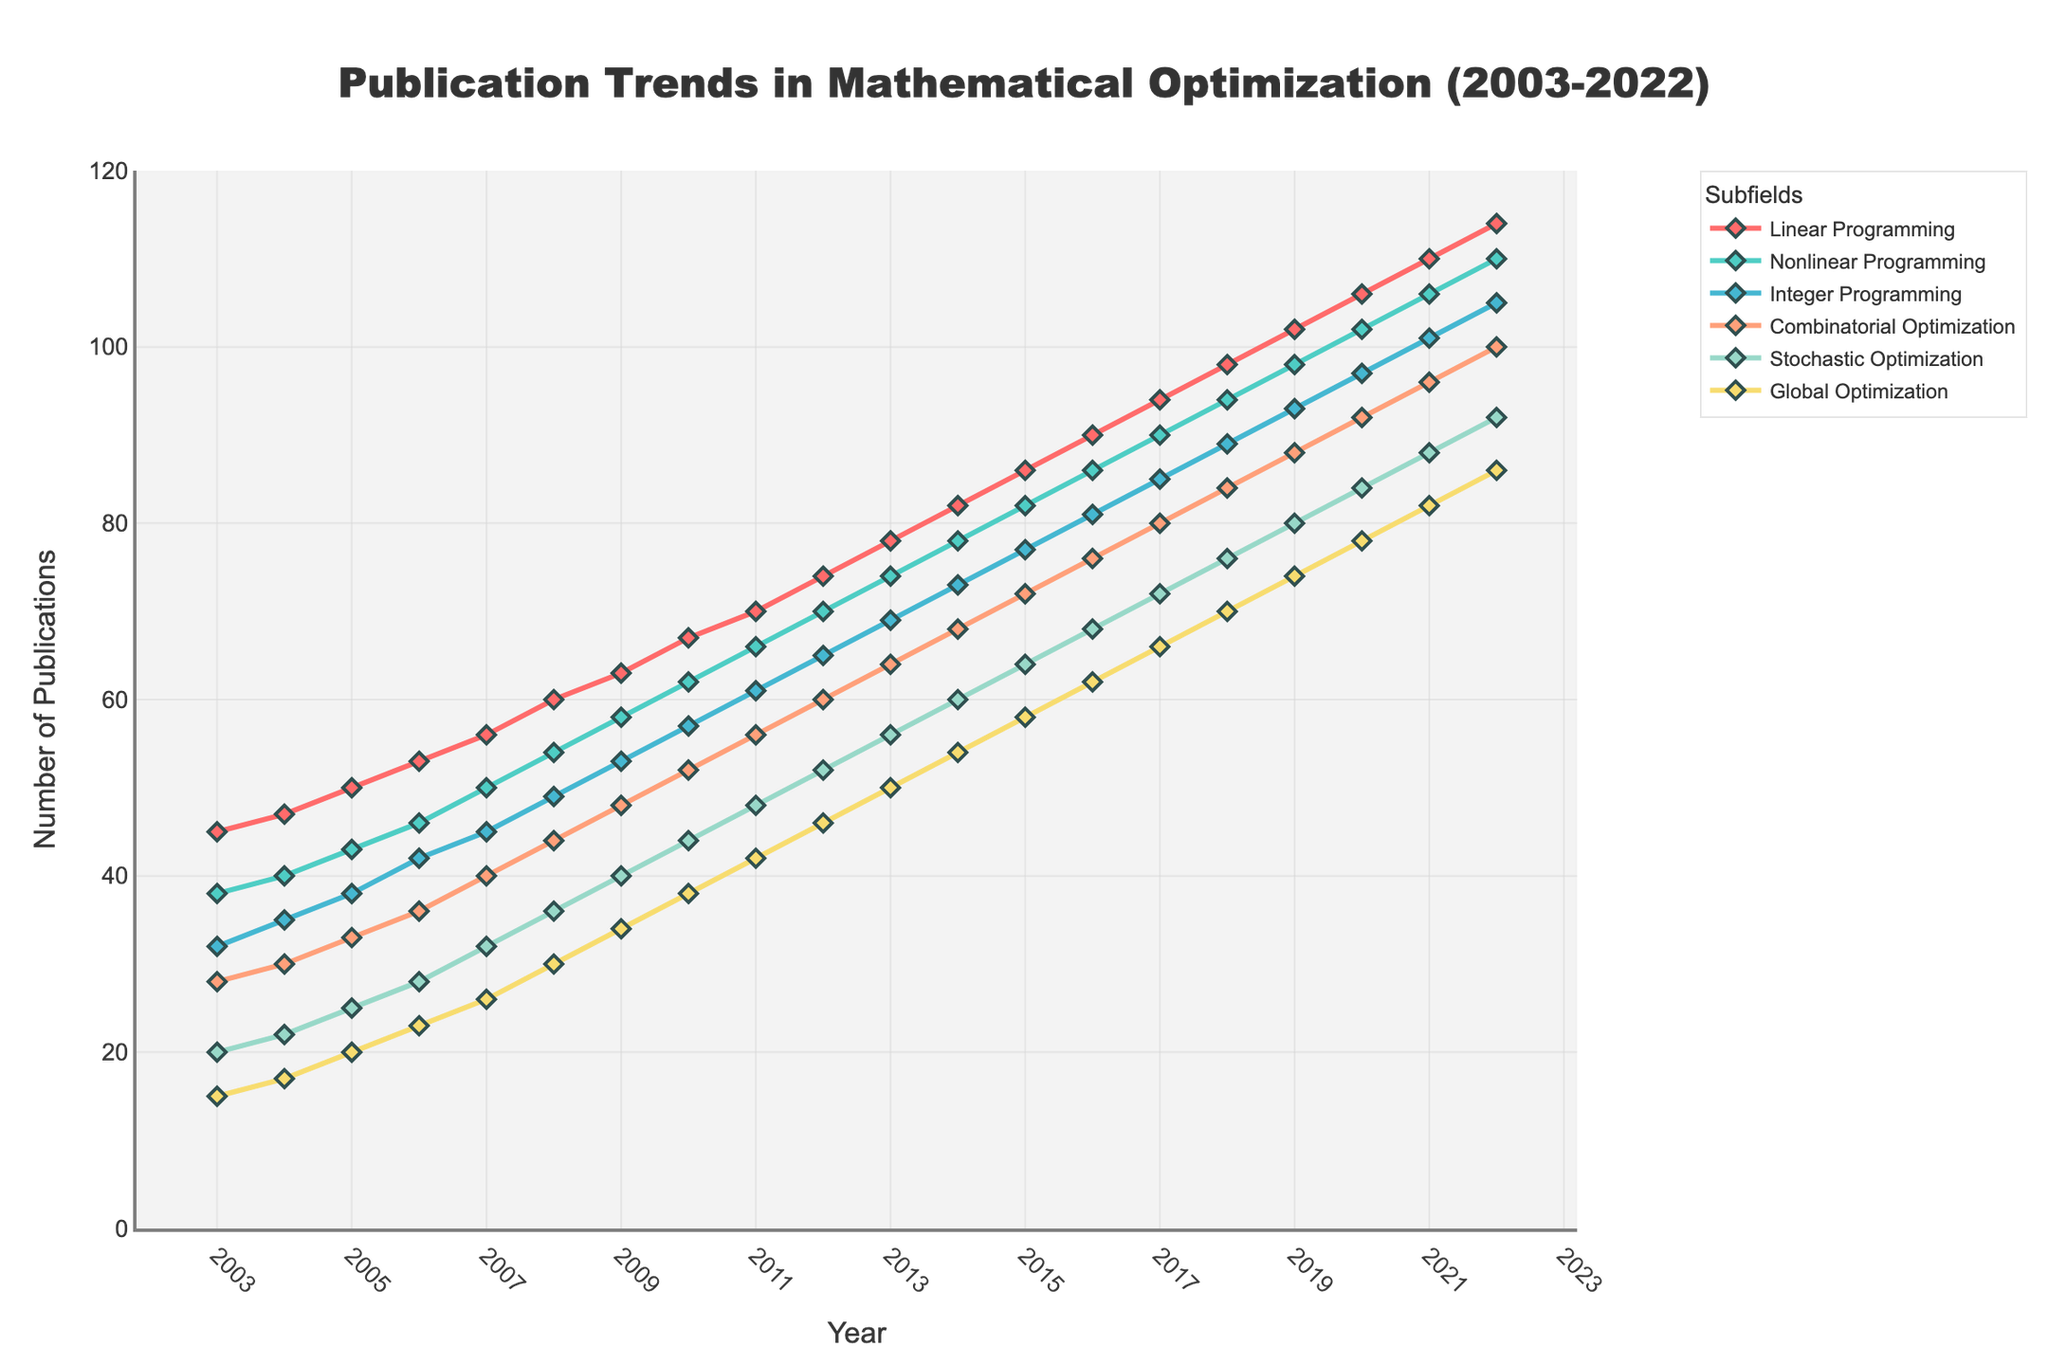What subfield has shown the highest increase in the number of publications from 2003 to 2022? To find the subfield with the highest increase, look at the endpoints for each line in the chart. Calculate the difference for each subfield between 2022 and 2003. Linear Programming has the highest difference (114 publications in 2022 minus 45 publications in 2003 = 69 publications increase).
Answer: Linear Programming Which subfields experienced a steady increase in publications over the entire period? Analyze the trend lines for each subfield. Identify lines that show a consistent upward trajectory without dips. All subfields show a steady increase: Linear Programming, Nonlinear Programming, Integer Programming, Combinatorial Optimization, Stochastic Optimization, Global Optimization.
Answer: All subfields What year saw Nonlinear Programming surpass 100 publications? Locate the Nonlinear Programming trend line, then identify the year when it crosses the 100 publications mark on the y-axis. In 2020, Nonlinear Programming surpassed 100 publications.
Answer: 2020 How does the number of publications in Integer Programming in 2010 compare to Combinatorial Optimization in the same year? Check the y-values of Integer Programming and Combinatorial Optimization for 2010 on the chart. Integer Programming has 57 publications while Combinatorial Optimization has 52 publications.
Answer: Integer Programming has 57, Combinatorial Optimization has 52 What is the average number of publications for Stochastic Optimization from 2003 to 2022? Sum the number of publications for Stochastic Optimization from each year, then divide by the number of years (20). The total is 1380 and the number of years is 20, so the average is 1380 / 20.
Answer: 69 Which subfield had the lowest number of publications in 2003, and what was the number? Check the y-values for all subfields in 2003. Global Optimization has the lowest value with 15 publications.
Answer: Global Optimization with 15 publications In what year did the number of publications in Global Optimization first exceed 50? Follow the Global Optimization trend line and identify the first year it crosses the 50 publications mark. In 2013, Global Optimization exceeded 50 publications.
Answer: 2013 What is the combined number of publications for all subfields in 2015? Sum the y-values for each subfield in 2015: 86 (Linear Programming) + 82 (Nonlinear Programming) + 77 (Integer Programming) + 72 (Combinatorial Optimization) + 64 (Stochastic Optimization) + 58 (Global Optimization) = 439.
Answer: 439 Which subfield has the steepest increase in publications between the years 2010 and 2020? Compare the slopes of the trend lines for each subfield between 2010 and 2020 by calculating the differences: Linear Programming (106-67=39), Nonlinear Programming (102-62=40), Integer Programming (97-57=40), Combinatorial Optimization (92-52=40), Stochastic Optimization (84-44=40), Global Optimization (78-38=40). The steepest increase is the same for Nonlinear Programming, Integer Programming, Combinatorial Optimization, Stochastic Optimization, and Global Optimization as all increased by 40.
Answer: Nonlinear Programming, Integer Programming, Combinatorial Optimization, Stochastic Optimization, Global Optimization 